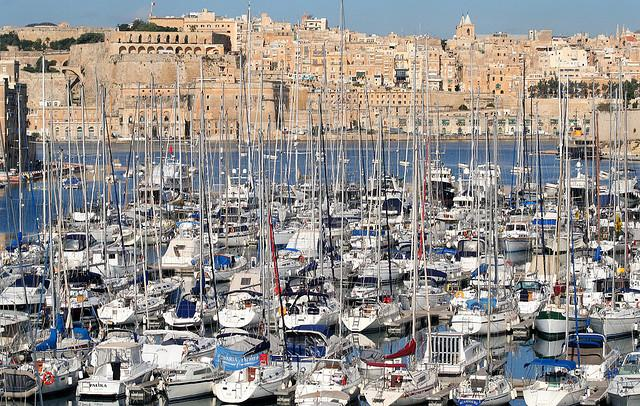What is a group of these abundant items called? boats 